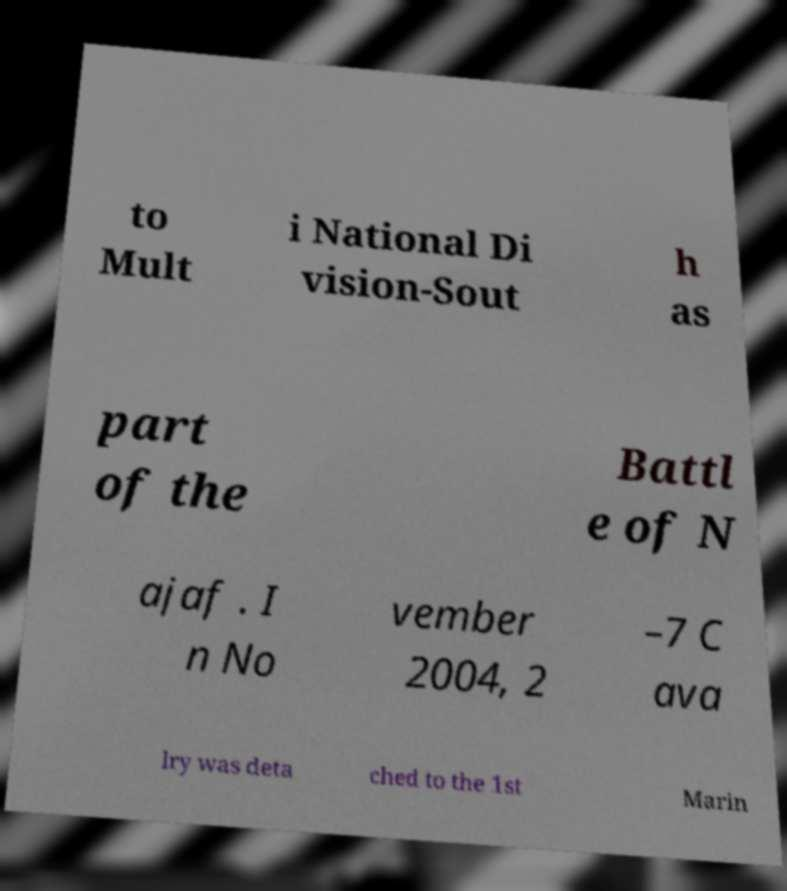For documentation purposes, I need the text within this image transcribed. Could you provide that? to Mult i National Di vision-Sout h as part of the Battl e of N ajaf . I n No vember 2004, 2 –7 C ava lry was deta ched to the 1st Marin 